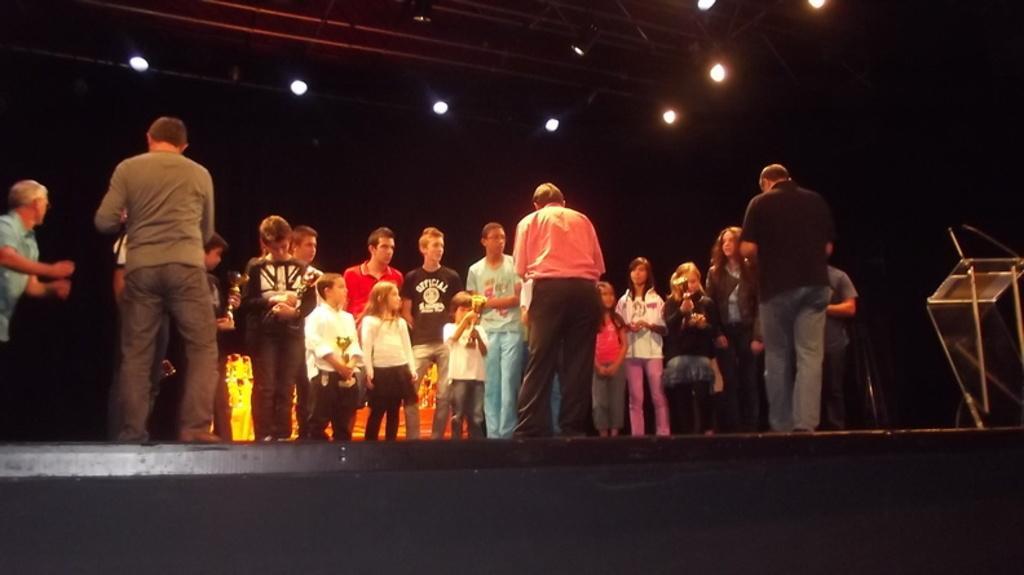Describe this image in one or two sentences. In this image we can see people standing. On the right there is a podium. In the background there are lights and curtains. 